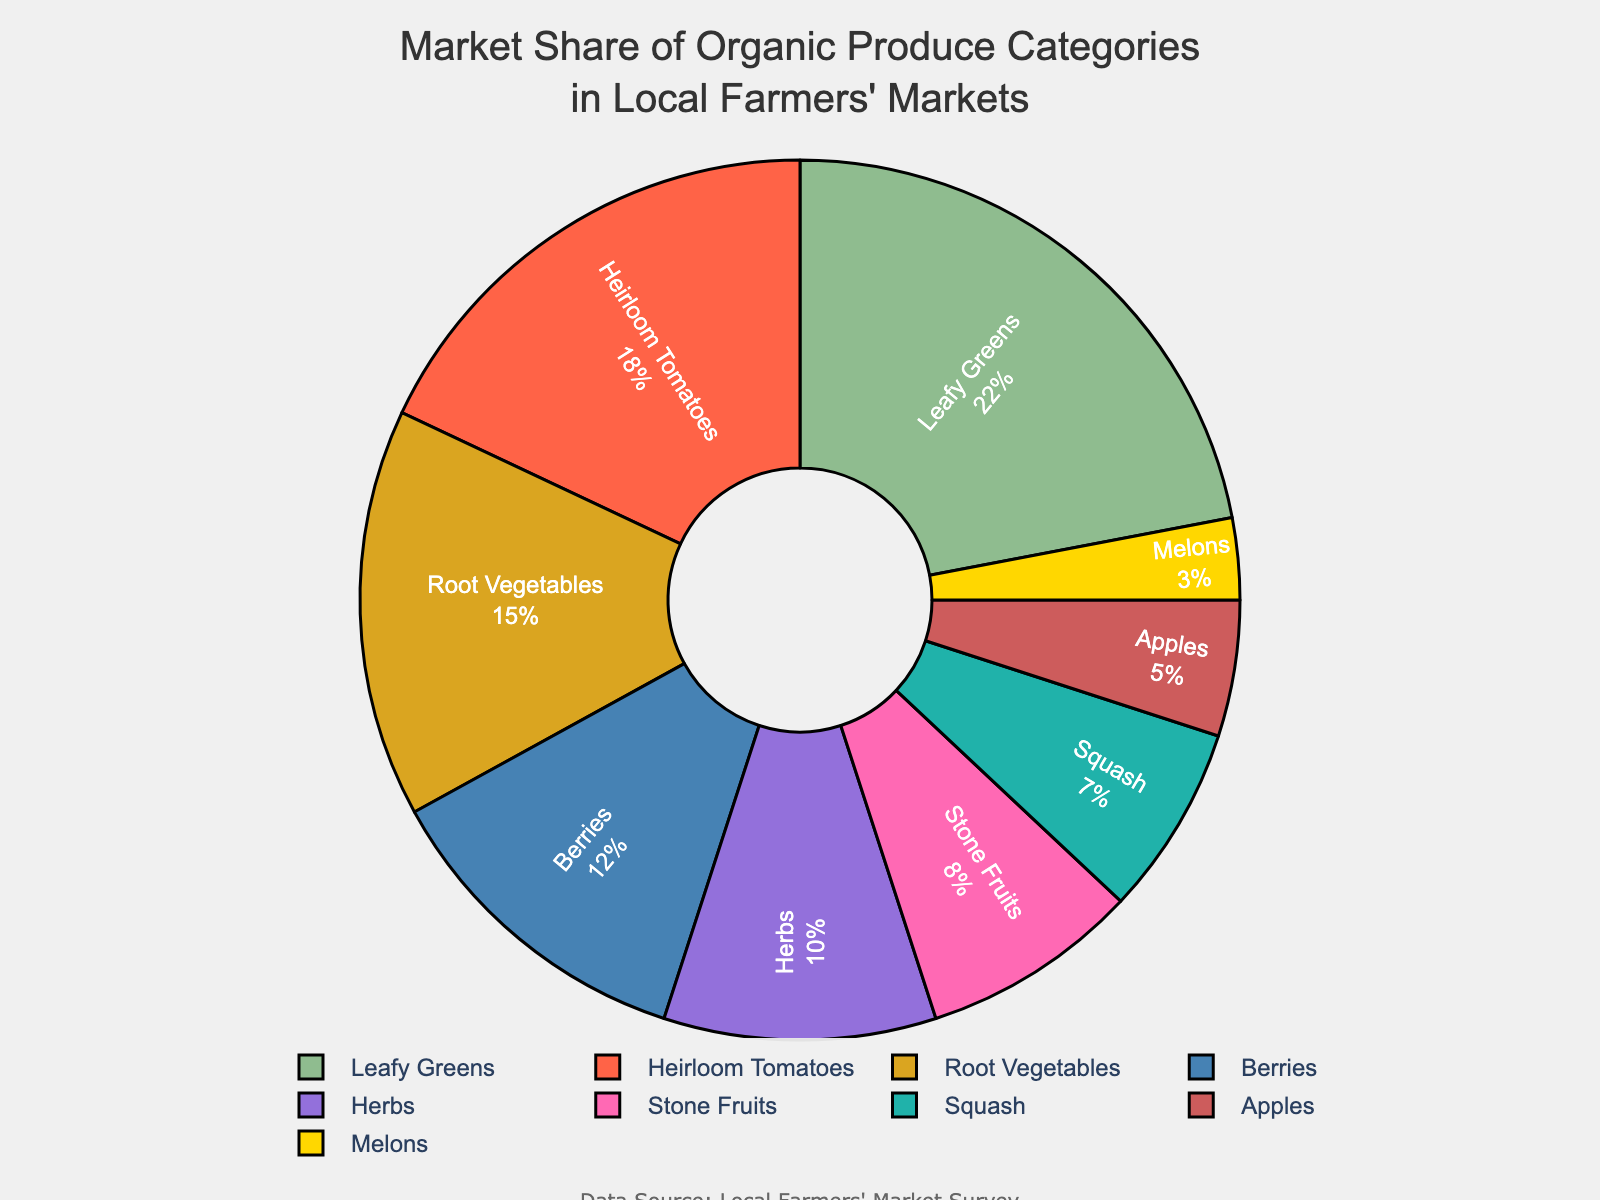What's the largest market share category for organic produce? Leafy Greens has the largest share. Just look at the size of the slices, and you'll see that the Leafy Greens section is the biggest.
Answer: Leafy Greens Which categories combined make up exactly 30% of the market share? By looking at the percentages on the chart, you can combine Root Vegetables (15%) and Berries (12%) which make up 27%, then adding Melons (3%) to make a total of 30%.
Answer: Root Vegetables, Berries, Melons Which category has a smaller market share than Stone Fruits but larger than Apples? Observing the chart, Squash has a market share of 7%, which is smaller than Stone Fruits (8%) but larger than Apples (5%).
Answer: Squash What is the difference in market share between the largest and the smallest categories? Subtract the market share of the smallest category (Melons at 3%) from the largest category (Leafy Greens at 22%). 22 - 3 = 19
Answer: 19 How do the market shares of Heirloom Tomatoes and Herbs compare to each other? Heirloom Tomatoes have 18% and Herbs have 10%. Heirloom Tomatoes have a larger market share.
Answer: Heirloom Tomatoes have a larger market share What is the average market share of Berries, Stone Fruits, and Apples? Sum their market shares first: Berries (12%) + Stone Fruits (8%) + Apples (5%) = 25%. Then divide by the number of categories: 25/3 ≈ 8.33
Answer: 8.33 If Leafy Greens reduced their market share by half, what would their new market share be? Half of Leafy Greens' 22% market share is calculated as 22 * 0.5 = 11
Answer: 11 Which category has a larger market share, Root Vegetables or Berries and Apples combined? The combined market share of Berries (12%) and Apples (5%) is 17%. Root Vegetables have a 15% market share, so Berries and Apples combined have a larger market share.
Answer: Berries and Apples combined What market share percentage is contributed by categories with at least 10% share each? Sum the market shares of Leafy Greens (22%), Heirloom Tomatoes (18%), Root Vegetables (15%), and Berries (12%): 22 + 18 + 15 + 12 = 67
Answer: 67 What is the total market share of all categories colored in warm tones? Warm tones include Heirloom Tomatoes (18%, red), Stone Fruits (8%, pink), Squash (7%, yellow), and Apples (5%, red). Sum these shares: 18 + 8 + 7 + 5 = 38
Answer: 38 